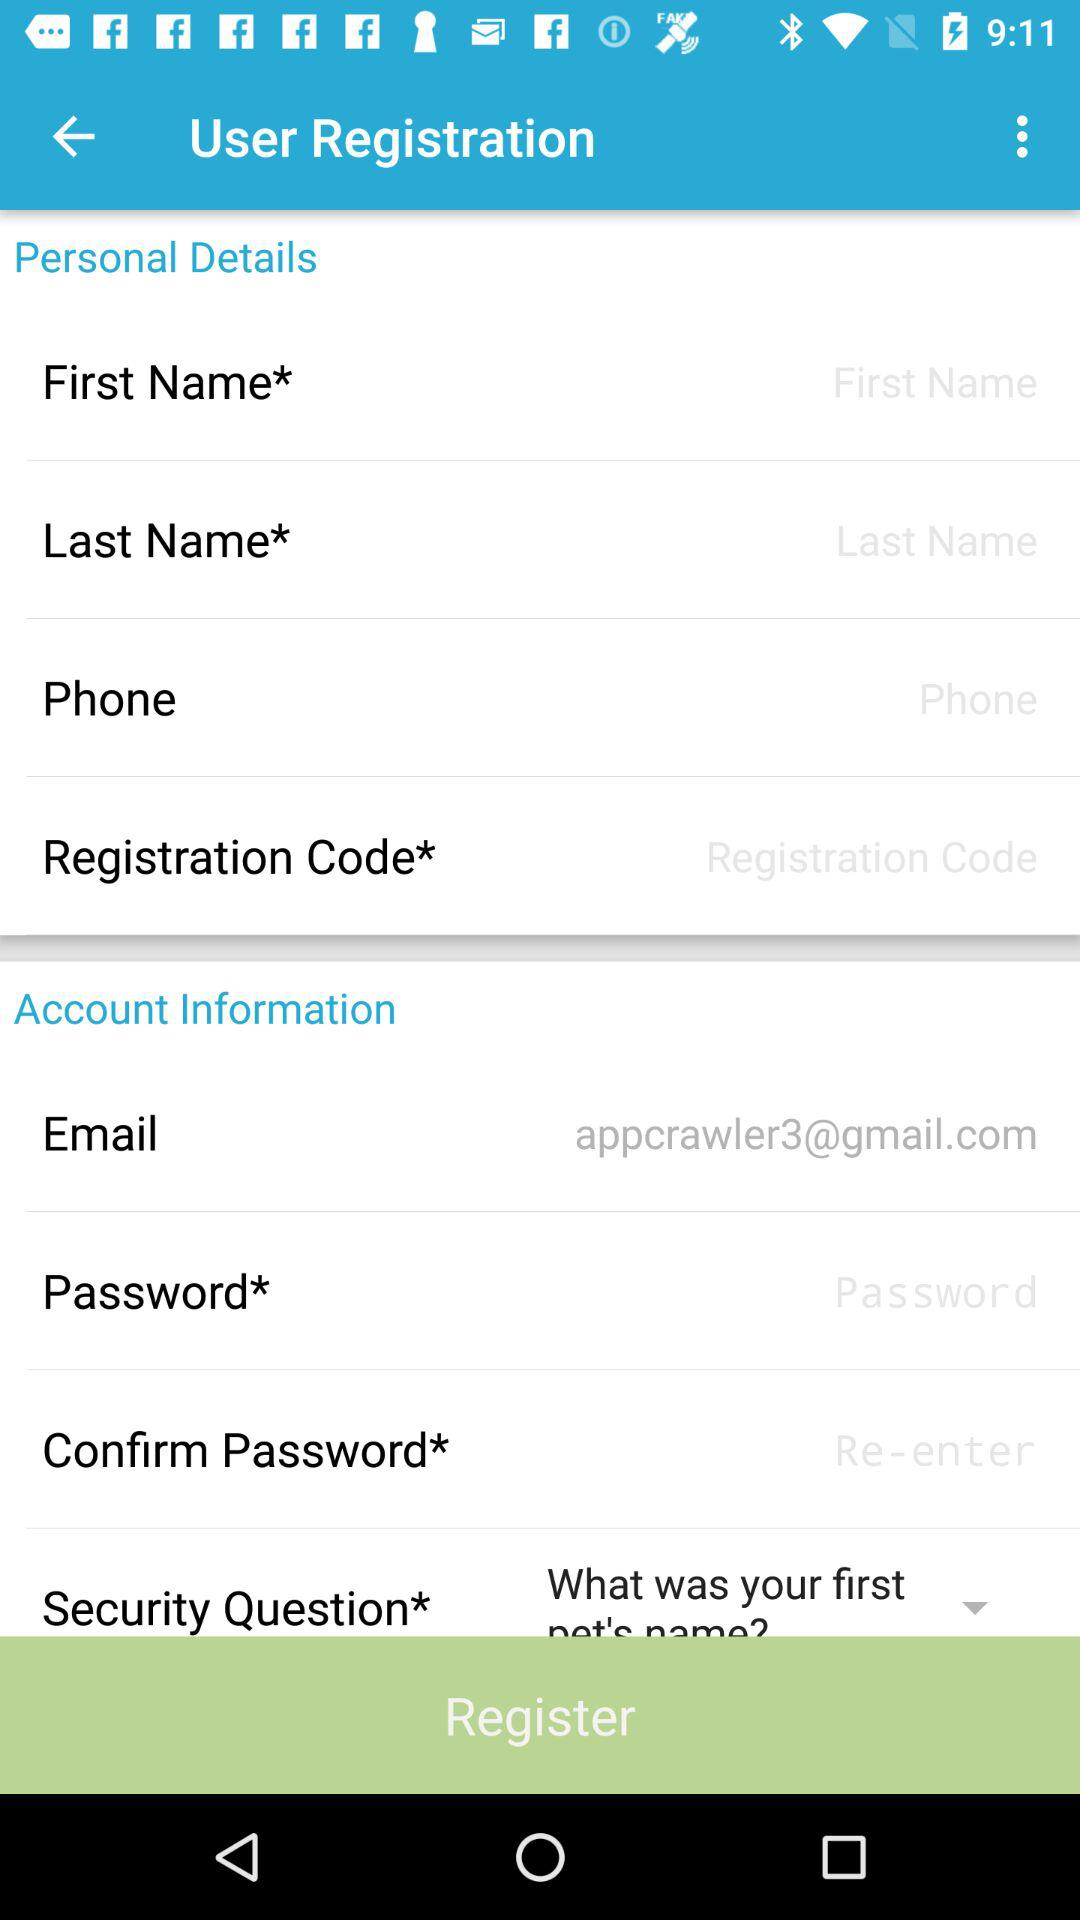Which is the selected security question? The selected security question is "What was your first pet's name?". 